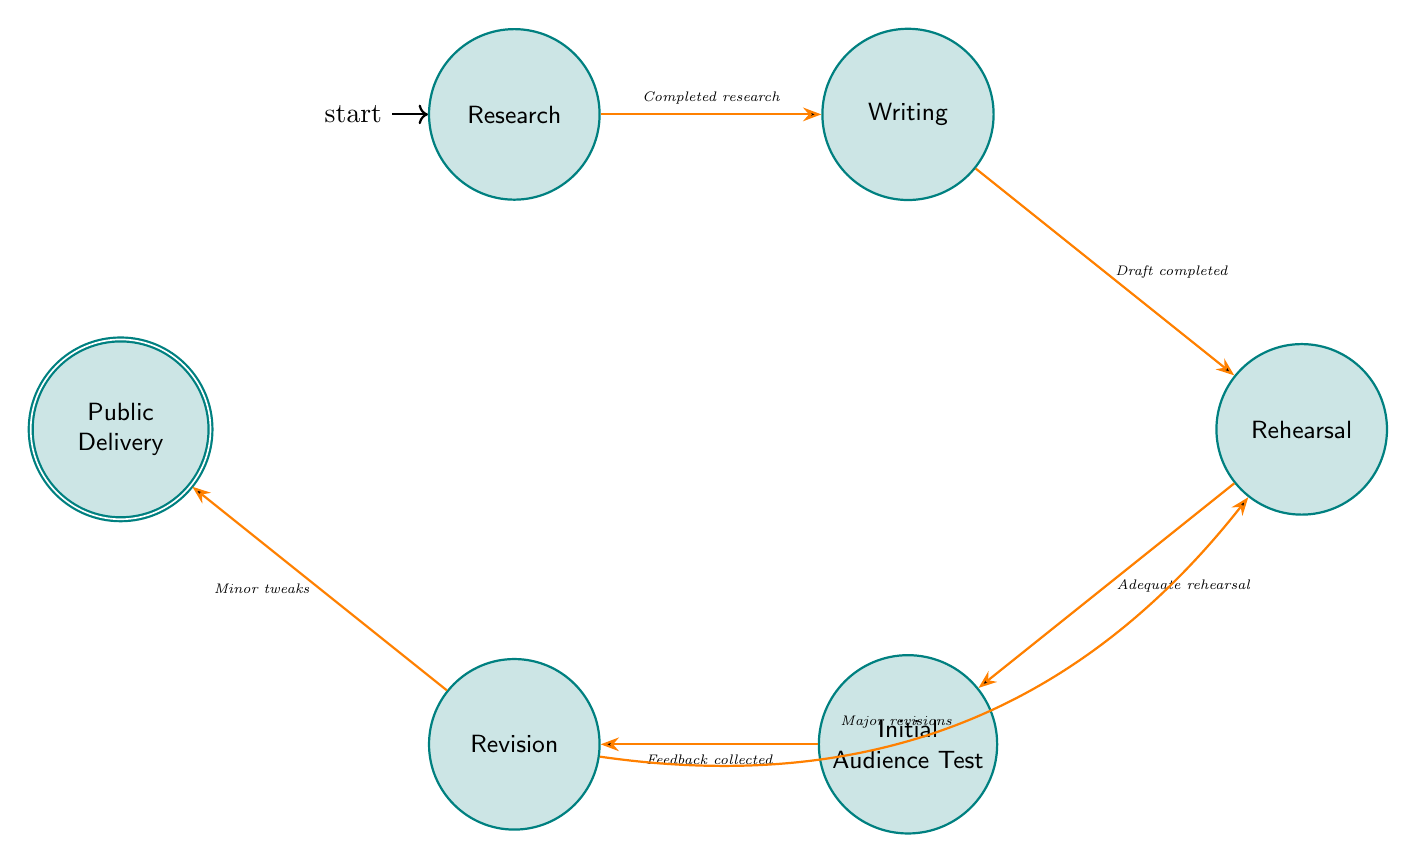What is the initial state of the diagram? The initial state is indicated by the "initial" label on the node, which is "Research." This means that the process starts at this node.
Answer: Research How many nodes are in the diagram? By counting the circles representing the states, we find there are six nodes: Research, Writing, Rehearsal, Initial Audience Test, Revision, and Public Delivery.
Answer: 6 What is the transition from "Rehearsal"? From the "Rehearsal" state, there are two transitions, one leading to "Initial Audience Test" labeled with "Adequate rehearsal" and the other leads back to "Revision" for "Major revisions."
Answer: Initial Audience Test and Revision Which state does the "Feedback collected" transition lead to? The "Feedback collected" transition comes from "Initial Audience Test" and directly leads to the "Revision" state.
Answer: Revision What happens after "Draft completed"? After the "Draft completed" trigger, the next state is "Rehearsal," indicating that once the draft is reviewed, the next step is practicing the speech.
Answer: Rehearsal What is the final state of the diagram? The final state is marked as "accepting," which is "Public Delivery." This indicates the end of the process where the speech is delivered at a public event.
Answer: Public Delivery If feedback leads to major revisions, what is the subsequent state? If major revisions are made after feedback, the next state is "Rehearsal" as indicated by the transition from "Revision" back to "Rehearsal."
Answer: Rehearsal Can you identify a state that has more than one outgoing transition? The "Revision" state has two outgoing transitions: one to "Rehearsal" for major revisions and another to "Public Delivery" for minor tweaks, showcasing that this state can lead to two different next steps.
Answer: Revision How does one transition from "Writing" to "Rehearsal"? Transitioning from "Writing" to "Rehearsal" occurs when the condition "Draft completed and reviewed by advisors" is satisfied, indicating the draft is ready for practice.
Answer: Rehearsal 